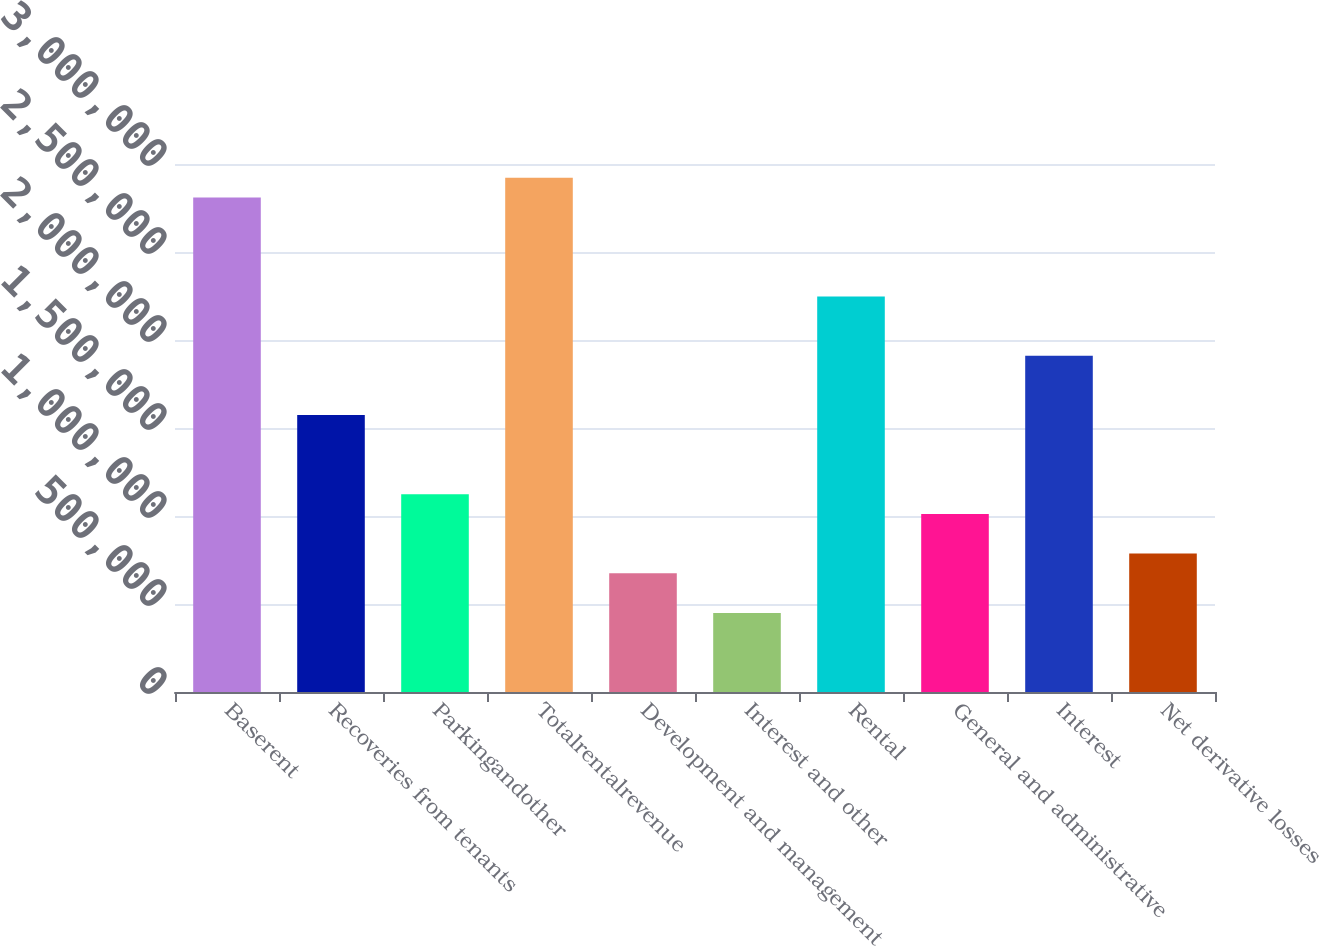<chart> <loc_0><loc_0><loc_500><loc_500><bar_chart><fcel>Baserent<fcel>Recoveries from tenants<fcel>Parkingandother<fcel>Totalrentalrevenue<fcel>Development and management<fcel>Interest and other<fcel>Rental<fcel>General and administrative<fcel>Interest<fcel>Net derivative losses<nl><fcel>2.80969e+06<fcel>1.57343e+06<fcel>1.12388e+06<fcel>2.92208e+06<fcel>674326<fcel>449551<fcel>2.24775e+06<fcel>1.01149e+06<fcel>1.91059e+06<fcel>786714<nl></chart> 